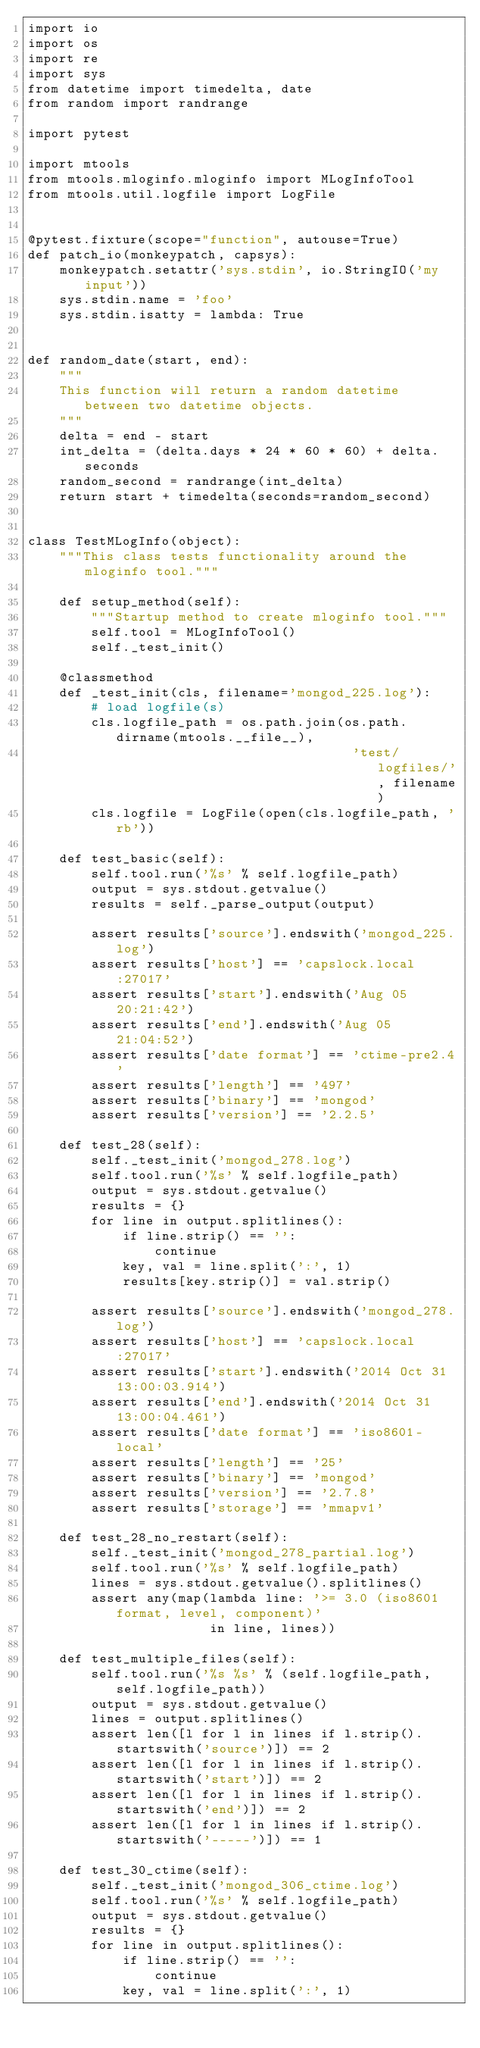<code> <loc_0><loc_0><loc_500><loc_500><_Python_>import io
import os
import re
import sys
from datetime import timedelta, date
from random import randrange

import pytest

import mtools
from mtools.mloginfo.mloginfo import MLogInfoTool
from mtools.util.logfile import LogFile


@pytest.fixture(scope="function", autouse=True)
def patch_io(monkeypatch, capsys):
    monkeypatch.setattr('sys.stdin', io.StringIO('my input'))
    sys.stdin.name = 'foo'
    sys.stdin.isatty = lambda: True


def random_date(start, end):
    """
    This function will return a random datetime between two datetime objects.
    """
    delta = end - start
    int_delta = (delta.days * 24 * 60 * 60) + delta.seconds
    random_second = randrange(int_delta)
    return start + timedelta(seconds=random_second)


class TestMLogInfo(object):
    """This class tests functionality around the mloginfo tool."""

    def setup_method(self):
        """Startup method to create mloginfo tool."""
        self.tool = MLogInfoTool()
        self._test_init()

    @classmethod
    def _test_init(cls, filename='mongod_225.log'):
        # load logfile(s)
        cls.logfile_path = os.path.join(os.path.dirname(mtools.__file__),
                                         'test/logfiles/', filename)
        cls.logfile = LogFile(open(cls.logfile_path, 'rb'))

    def test_basic(self):
        self.tool.run('%s' % self.logfile_path)
        output = sys.stdout.getvalue()
        results = self._parse_output(output)

        assert results['source'].endswith('mongod_225.log')
        assert results['host'] == 'capslock.local:27017'
        assert results['start'].endswith('Aug 05 20:21:42')
        assert results['end'].endswith('Aug 05 21:04:52')
        assert results['date format'] == 'ctime-pre2.4'
        assert results['length'] == '497'
        assert results['binary'] == 'mongod'
        assert results['version'] == '2.2.5'

    def test_28(self):
        self._test_init('mongod_278.log')
        self.tool.run('%s' % self.logfile_path)
        output = sys.stdout.getvalue()
        results = {}
        for line in output.splitlines():
            if line.strip() == '':
                continue
            key, val = line.split(':', 1)
            results[key.strip()] = val.strip()

        assert results['source'].endswith('mongod_278.log')
        assert results['host'] == 'capslock.local:27017'
        assert results['start'].endswith('2014 Oct 31 13:00:03.914')
        assert results['end'].endswith('2014 Oct 31 13:00:04.461')
        assert results['date format'] == 'iso8601-local'
        assert results['length'] == '25'
        assert results['binary'] == 'mongod'
        assert results['version'] == '2.7.8'
        assert results['storage'] == 'mmapv1'

    def test_28_no_restart(self):
        self._test_init('mongod_278_partial.log')
        self.tool.run('%s' % self.logfile_path)
        lines = sys.stdout.getvalue().splitlines()
        assert any(map(lambda line: '>= 3.0 (iso8601 format, level, component)'
                       in line, lines))

    def test_multiple_files(self):
        self.tool.run('%s %s' % (self.logfile_path, self.logfile_path))
        output = sys.stdout.getvalue()
        lines = output.splitlines()
        assert len([l for l in lines if l.strip().startswith('source')]) == 2
        assert len([l for l in lines if l.strip().startswith('start')]) == 2
        assert len([l for l in lines if l.strip().startswith('end')]) == 2
        assert len([l for l in lines if l.strip().startswith('-----')]) == 1

    def test_30_ctime(self):
        self._test_init('mongod_306_ctime.log')
        self.tool.run('%s' % self.logfile_path)
        output = sys.stdout.getvalue()
        results = {}
        for line in output.splitlines():
            if line.strip() == '':
                continue
            key, val = line.split(':', 1)</code> 